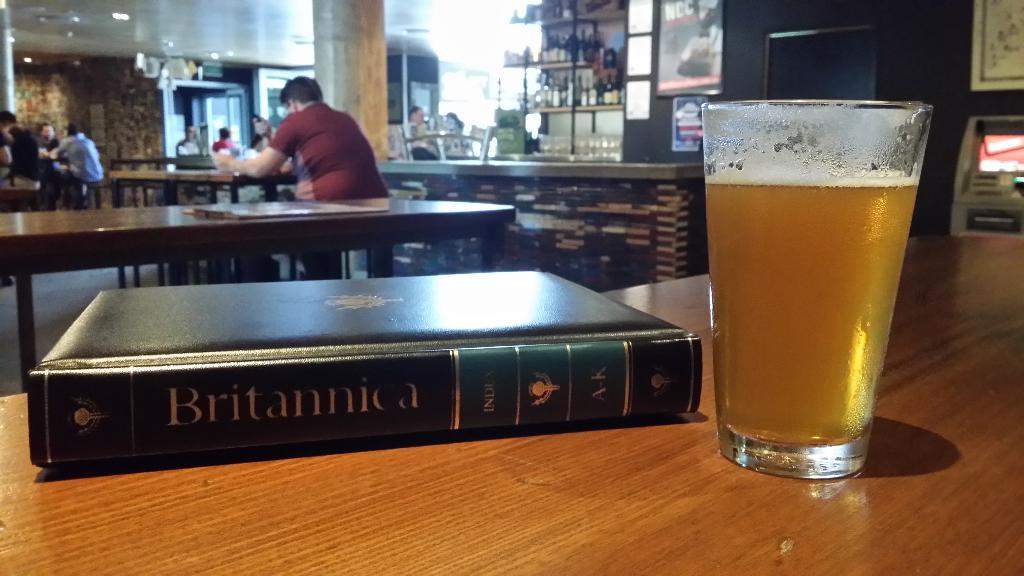<image>
Describe the image concisely. A book titled Britannica next to a full glass. 